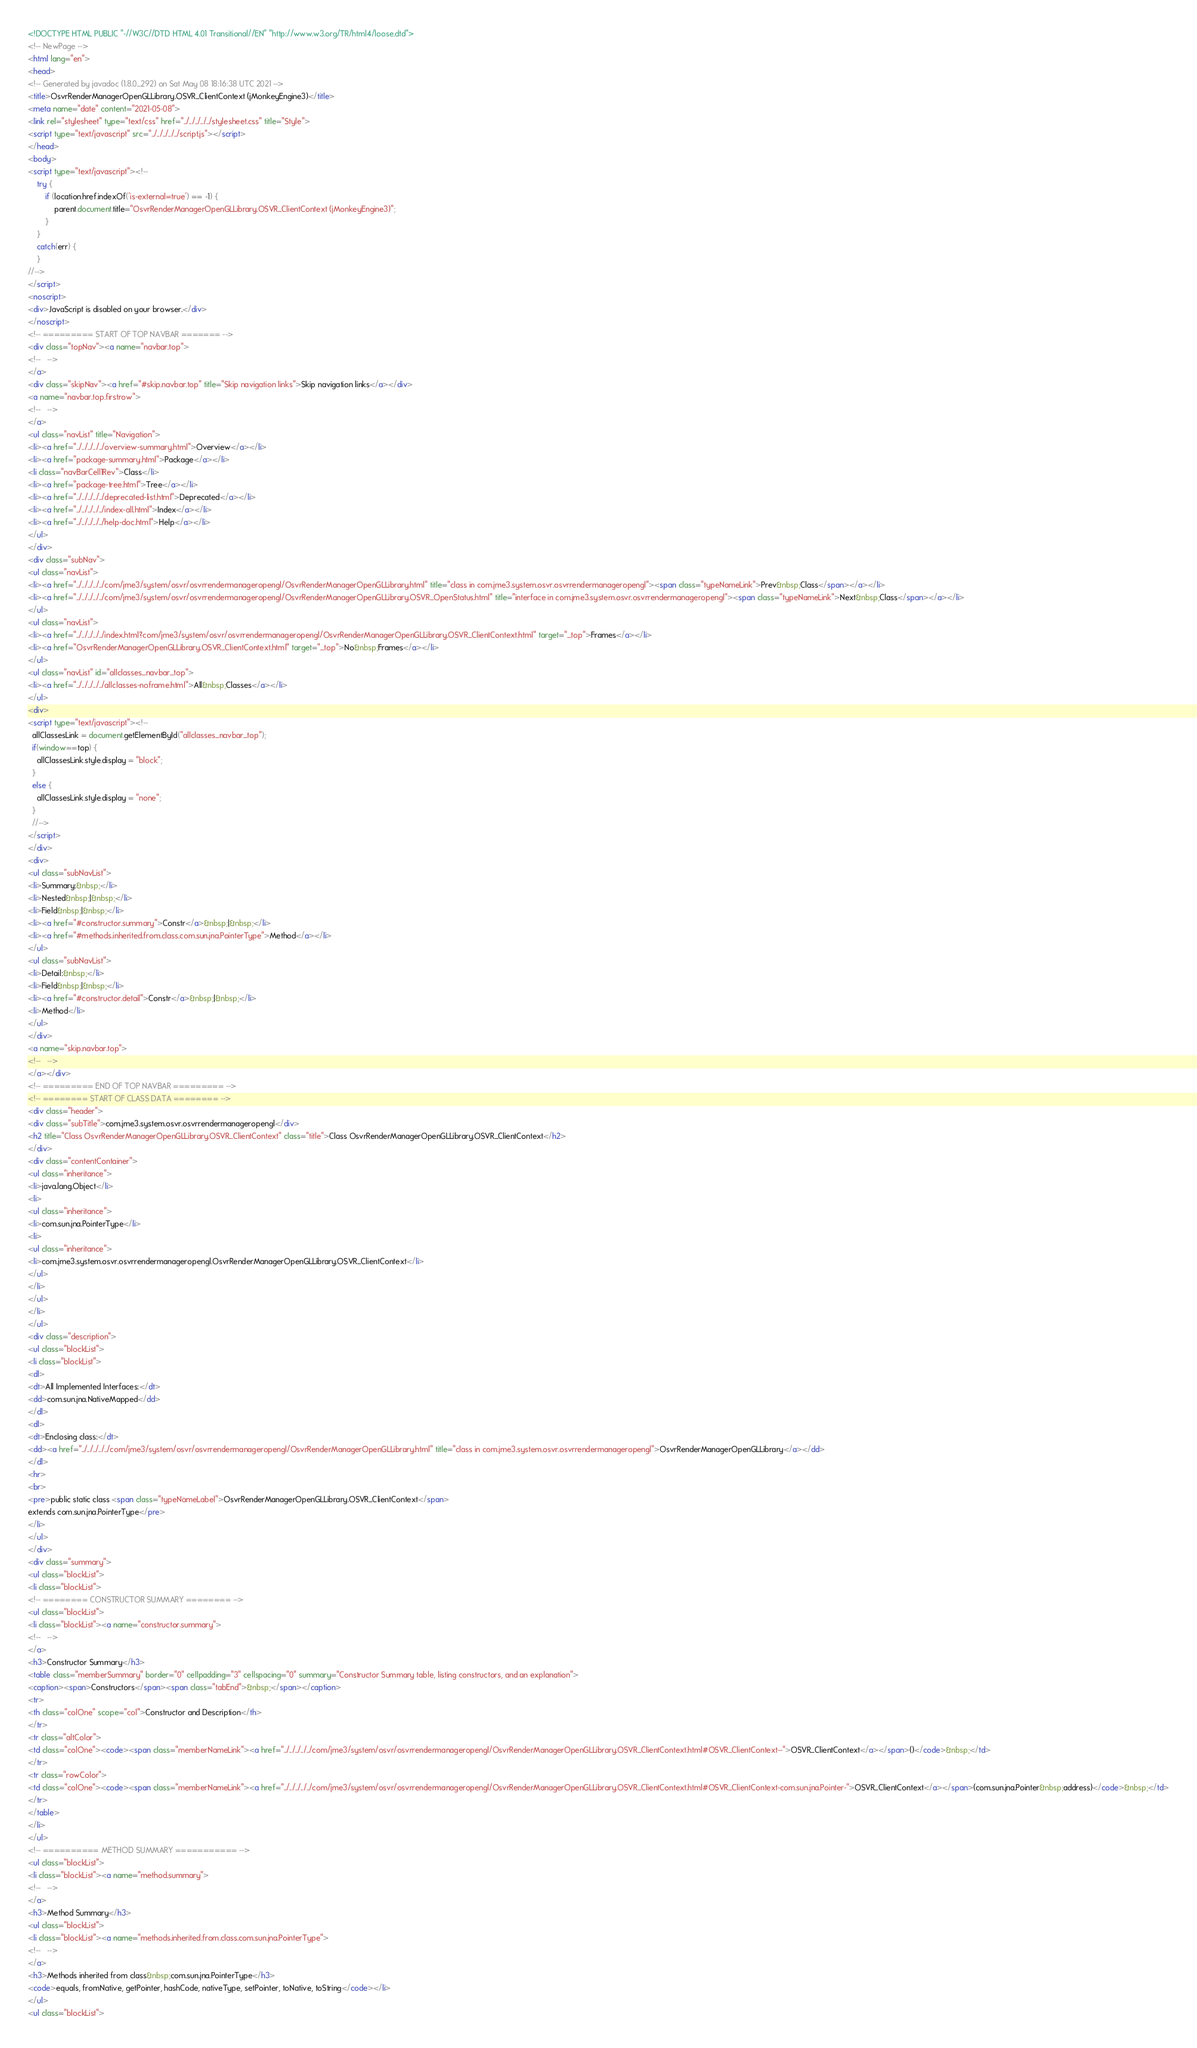Convert code to text. <code><loc_0><loc_0><loc_500><loc_500><_HTML_><!DOCTYPE HTML PUBLIC "-//W3C//DTD HTML 4.01 Transitional//EN" "http://www.w3.org/TR/html4/loose.dtd">
<!-- NewPage -->
<html lang="en">
<head>
<!-- Generated by javadoc (1.8.0_292) on Sat May 08 18:16:38 UTC 2021 -->
<title>OsvrRenderManagerOpenGLLibrary.OSVR_ClientContext (jMonkeyEngine3)</title>
<meta name="date" content="2021-05-08">
<link rel="stylesheet" type="text/css" href="../../../../../stylesheet.css" title="Style">
<script type="text/javascript" src="../../../../../script.js"></script>
</head>
<body>
<script type="text/javascript"><!--
    try {
        if (location.href.indexOf('is-external=true') == -1) {
            parent.document.title="OsvrRenderManagerOpenGLLibrary.OSVR_ClientContext (jMonkeyEngine3)";
        }
    }
    catch(err) {
    }
//-->
</script>
<noscript>
<div>JavaScript is disabled on your browser.</div>
</noscript>
<!-- ========= START OF TOP NAVBAR ======= -->
<div class="topNav"><a name="navbar.top">
<!--   -->
</a>
<div class="skipNav"><a href="#skip.navbar.top" title="Skip navigation links">Skip navigation links</a></div>
<a name="navbar.top.firstrow">
<!--   -->
</a>
<ul class="navList" title="Navigation">
<li><a href="../../../../../overview-summary.html">Overview</a></li>
<li><a href="package-summary.html">Package</a></li>
<li class="navBarCell1Rev">Class</li>
<li><a href="package-tree.html">Tree</a></li>
<li><a href="../../../../../deprecated-list.html">Deprecated</a></li>
<li><a href="../../../../../index-all.html">Index</a></li>
<li><a href="../../../../../help-doc.html">Help</a></li>
</ul>
</div>
<div class="subNav">
<ul class="navList">
<li><a href="../../../../../com/jme3/system/osvr/osvrrendermanageropengl/OsvrRenderManagerOpenGLLibrary.html" title="class in com.jme3.system.osvr.osvrrendermanageropengl"><span class="typeNameLink">Prev&nbsp;Class</span></a></li>
<li><a href="../../../../../com/jme3/system/osvr/osvrrendermanageropengl/OsvrRenderManagerOpenGLLibrary.OSVR_OpenStatus.html" title="interface in com.jme3.system.osvr.osvrrendermanageropengl"><span class="typeNameLink">Next&nbsp;Class</span></a></li>
</ul>
<ul class="navList">
<li><a href="../../../../../index.html?com/jme3/system/osvr/osvrrendermanageropengl/OsvrRenderManagerOpenGLLibrary.OSVR_ClientContext.html" target="_top">Frames</a></li>
<li><a href="OsvrRenderManagerOpenGLLibrary.OSVR_ClientContext.html" target="_top">No&nbsp;Frames</a></li>
</ul>
<ul class="navList" id="allclasses_navbar_top">
<li><a href="../../../../../allclasses-noframe.html">All&nbsp;Classes</a></li>
</ul>
<div>
<script type="text/javascript"><!--
  allClassesLink = document.getElementById("allclasses_navbar_top");
  if(window==top) {
    allClassesLink.style.display = "block";
  }
  else {
    allClassesLink.style.display = "none";
  }
  //-->
</script>
</div>
<div>
<ul class="subNavList">
<li>Summary:&nbsp;</li>
<li>Nested&nbsp;|&nbsp;</li>
<li>Field&nbsp;|&nbsp;</li>
<li><a href="#constructor.summary">Constr</a>&nbsp;|&nbsp;</li>
<li><a href="#methods.inherited.from.class.com.sun.jna.PointerType">Method</a></li>
</ul>
<ul class="subNavList">
<li>Detail:&nbsp;</li>
<li>Field&nbsp;|&nbsp;</li>
<li><a href="#constructor.detail">Constr</a>&nbsp;|&nbsp;</li>
<li>Method</li>
</ul>
</div>
<a name="skip.navbar.top">
<!--   -->
</a></div>
<!-- ========= END OF TOP NAVBAR ========= -->
<!-- ======== START OF CLASS DATA ======== -->
<div class="header">
<div class="subTitle">com.jme3.system.osvr.osvrrendermanageropengl</div>
<h2 title="Class OsvrRenderManagerOpenGLLibrary.OSVR_ClientContext" class="title">Class OsvrRenderManagerOpenGLLibrary.OSVR_ClientContext</h2>
</div>
<div class="contentContainer">
<ul class="inheritance">
<li>java.lang.Object</li>
<li>
<ul class="inheritance">
<li>com.sun.jna.PointerType</li>
<li>
<ul class="inheritance">
<li>com.jme3.system.osvr.osvrrendermanageropengl.OsvrRenderManagerOpenGLLibrary.OSVR_ClientContext</li>
</ul>
</li>
</ul>
</li>
</ul>
<div class="description">
<ul class="blockList">
<li class="blockList">
<dl>
<dt>All Implemented Interfaces:</dt>
<dd>com.sun.jna.NativeMapped</dd>
</dl>
<dl>
<dt>Enclosing class:</dt>
<dd><a href="../../../../../com/jme3/system/osvr/osvrrendermanageropengl/OsvrRenderManagerOpenGLLibrary.html" title="class in com.jme3.system.osvr.osvrrendermanageropengl">OsvrRenderManagerOpenGLLibrary</a></dd>
</dl>
<hr>
<br>
<pre>public static class <span class="typeNameLabel">OsvrRenderManagerOpenGLLibrary.OSVR_ClientContext</span>
extends com.sun.jna.PointerType</pre>
</li>
</ul>
</div>
<div class="summary">
<ul class="blockList">
<li class="blockList">
<!-- ======== CONSTRUCTOR SUMMARY ======== -->
<ul class="blockList">
<li class="blockList"><a name="constructor.summary">
<!--   -->
</a>
<h3>Constructor Summary</h3>
<table class="memberSummary" border="0" cellpadding="3" cellspacing="0" summary="Constructor Summary table, listing constructors, and an explanation">
<caption><span>Constructors</span><span class="tabEnd">&nbsp;</span></caption>
<tr>
<th class="colOne" scope="col">Constructor and Description</th>
</tr>
<tr class="altColor">
<td class="colOne"><code><span class="memberNameLink"><a href="../../../../../com/jme3/system/osvr/osvrrendermanageropengl/OsvrRenderManagerOpenGLLibrary.OSVR_ClientContext.html#OSVR_ClientContext--">OSVR_ClientContext</a></span>()</code>&nbsp;</td>
</tr>
<tr class="rowColor">
<td class="colOne"><code><span class="memberNameLink"><a href="../../../../../com/jme3/system/osvr/osvrrendermanageropengl/OsvrRenderManagerOpenGLLibrary.OSVR_ClientContext.html#OSVR_ClientContext-com.sun.jna.Pointer-">OSVR_ClientContext</a></span>(com.sun.jna.Pointer&nbsp;address)</code>&nbsp;</td>
</tr>
</table>
</li>
</ul>
<!-- ========== METHOD SUMMARY =========== -->
<ul class="blockList">
<li class="blockList"><a name="method.summary">
<!--   -->
</a>
<h3>Method Summary</h3>
<ul class="blockList">
<li class="blockList"><a name="methods.inherited.from.class.com.sun.jna.PointerType">
<!--   -->
</a>
<h3>Methods inherited from class&nbsp;com.sun.jna.PointerType</h3>
<code>equals, fromNative, getPointer, hashCode, nativeType, setPointer, toNative, toString</code></li>
</ul>
<ul class="blockList"></code> 